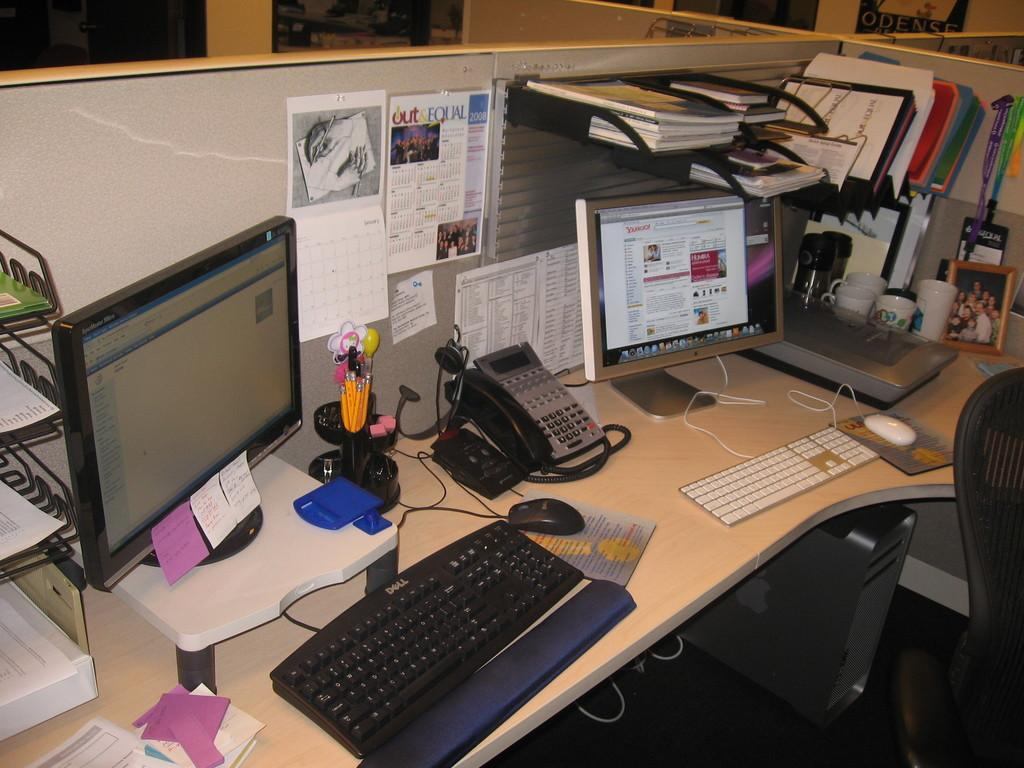What type of furniture is present in the image? There is a table in the image. What electronic device is on the table? There is a system (computer) on the table. What communication device is on the table? There is a telephone on the table. What input device is on the table? There is a mouse on the table. What input device is also on the table? There is a keyboard on the table. What type of accessory is on the table? There are caps (presumably a cap or a hat) on the table. What type of decorative item is on the table? There is a photo frame on the table. What type of educational or informational items are on the table? There are books on the table. What type of writing material is on the table? There is paper on the table. What type of environment does the image appear to depict? The setting appears to be an office. What type of boot can be seen in the image? There is no boot present in the image. What activity is taking place in the image? The image does not depict a specific activity; it shows various items on a table in an office setting. 